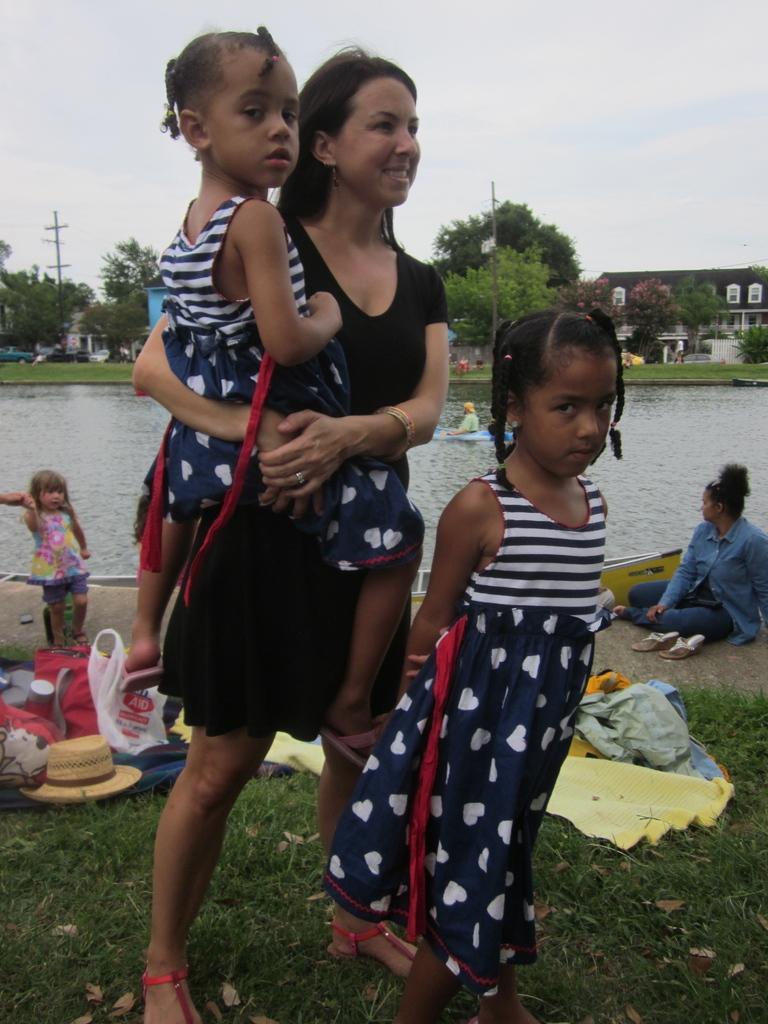Please provide a concise description of this image. In this picture we can observe a woman standing on the ground. There are two girls. The woman is holding one of the girls and the other is standing on the ground. We can observe some grass on the ground. There are some bags and a hat placed on the ground. In the background we can observe a pond. There are some trees and a building. In the background we can observe a sky. 